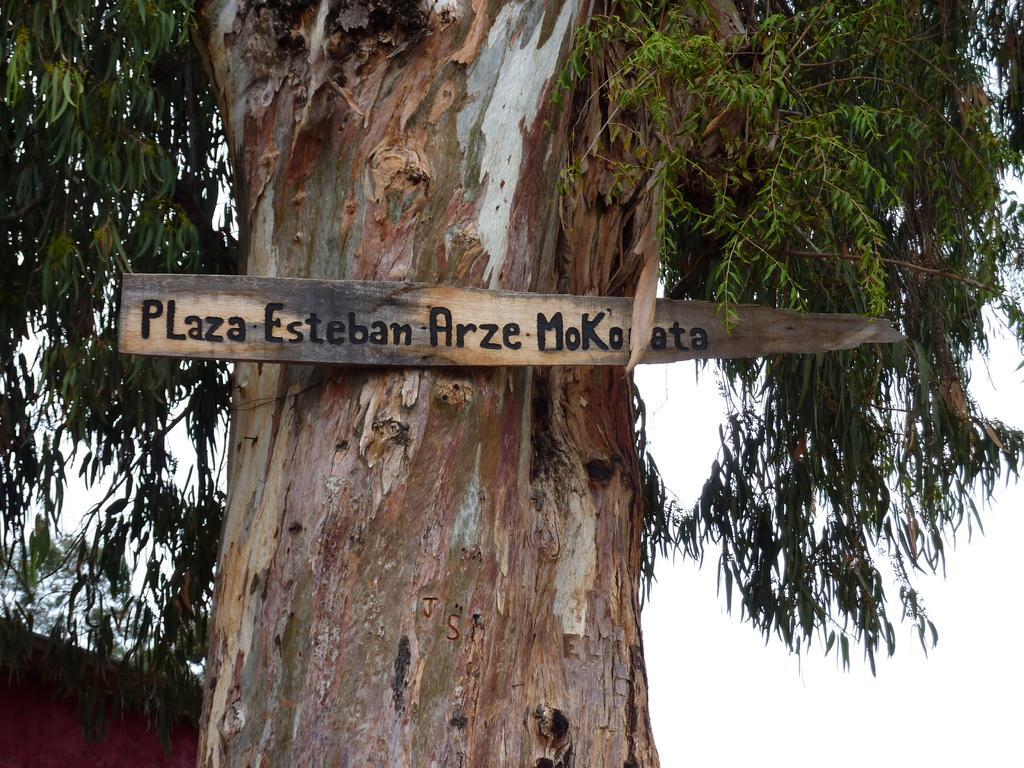Can you describe this image briefly? In this image there is some text on the wooden plank and the plank is on the trunk of a tree. On the left side of the image there is a house. In the background of the image there is sky. 